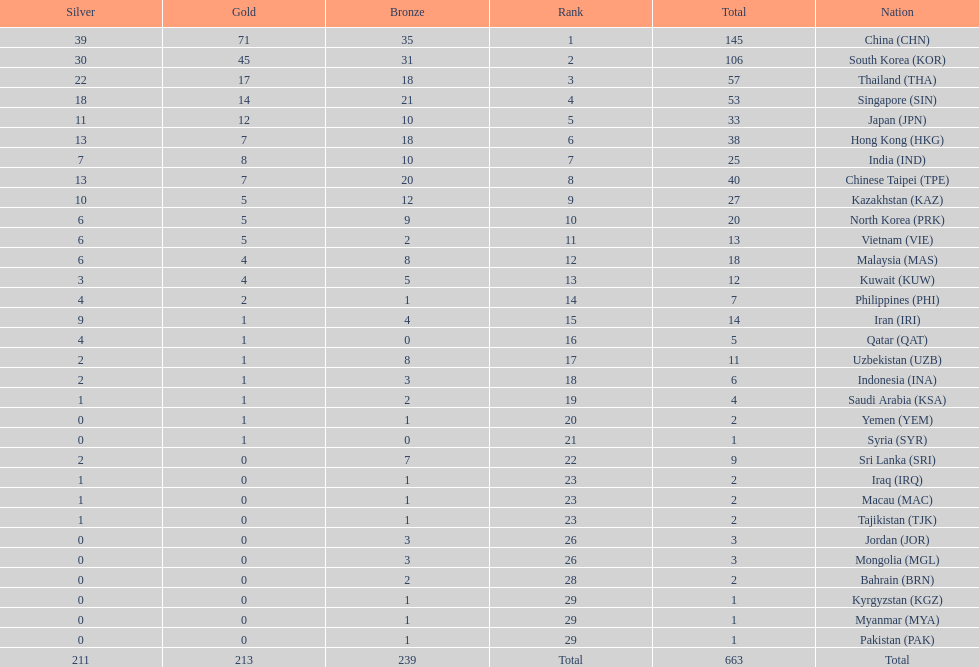How many countries have at least 10 gold medals in the asian youth games? 5. 